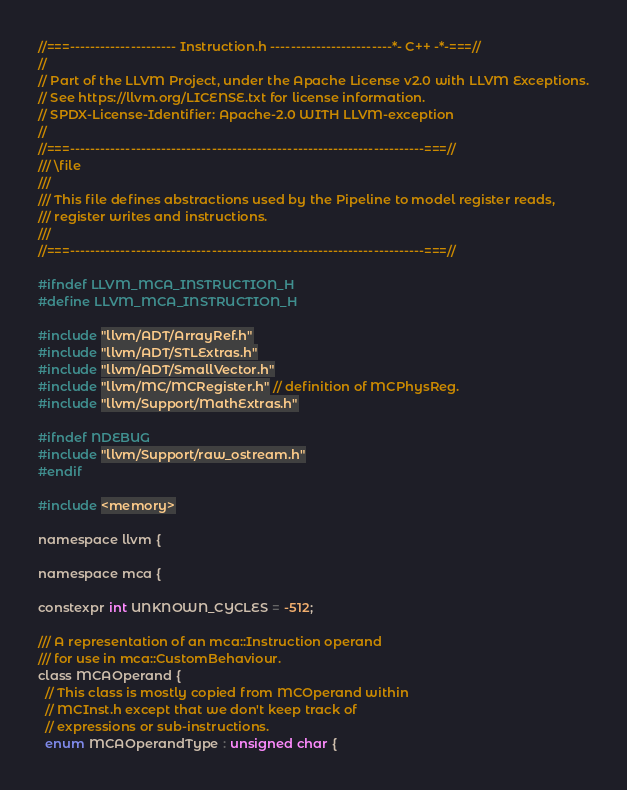Convert code to text. <code><loc_0><loc_0><loc_500><loc_500><_C_>//===--------------------- Instruction.h ------------------------*- C++ -*-===//
//
// Part of the LLVM Project, under the Apache License v2.0 with LLVM Exceptions.
// See https://llvm.org/LICENSE.txt for license information.
// SPDX-License-Identifier: Apache-2.0 WITH LLVM-exception
//
//===----------------------------------------------------------------------===//
/// \file
///
/// This file defines abstractions used by the Pipeline to model register reads,
/// register writes and instructions.
///
//===----------------------------------------------------------------------===//

#ifndef LLVM_MCA_INSTRUCTION_H
#define LLVM_MCA_INSTRUCTION_H

#include "llvm/ADT/ArrayRef.h"
#include "llvm/ADT/STLExtras.h"
#include "llvm/ADT/SmallVector.h"
#include "llvm/MC/MCRegister.h" // definition of MCPhysReg.
#include "llvm/Support/MathExtras.h"

#ifndef NDEBUG
#include "llvm/Support/raw_ostream.h"
#endif

#include <memory>

namespace llvm {

namespace mca {

constexpr int UNKNOWN_CYCLES = -512;

/// A representation of an mca::Instruction operand
/// for use in mca::CustomBehaviour.
class MCAOperand {
  // This class is mostly copied from MCOperand within
  // MCInst.h except that we don't keep track of
  // expressions or sub-instructions.
  enum MCAOperandType : unsigned char {</code> 